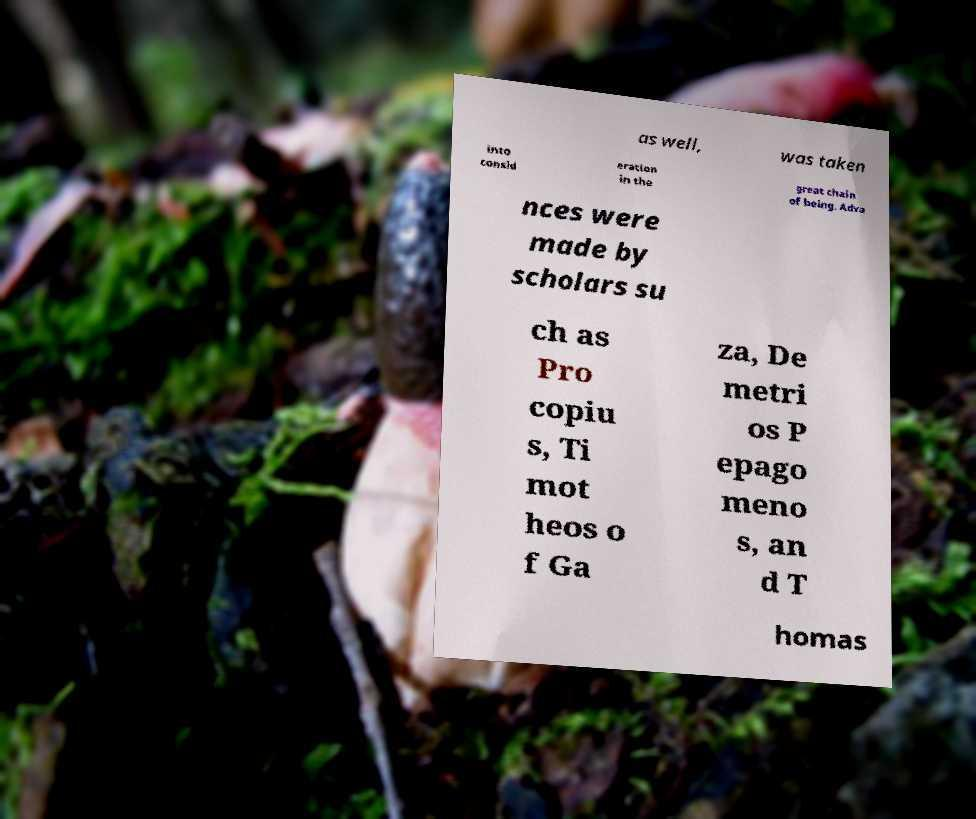Please identify and transcribe the text found in this image. as well, was taken into consid eration in the great chain of being. Adva nces were made by scholars su ch as Pro copiu s, Ti mot heos o f Ga za, De metri os P epago meno s, an d T homas 